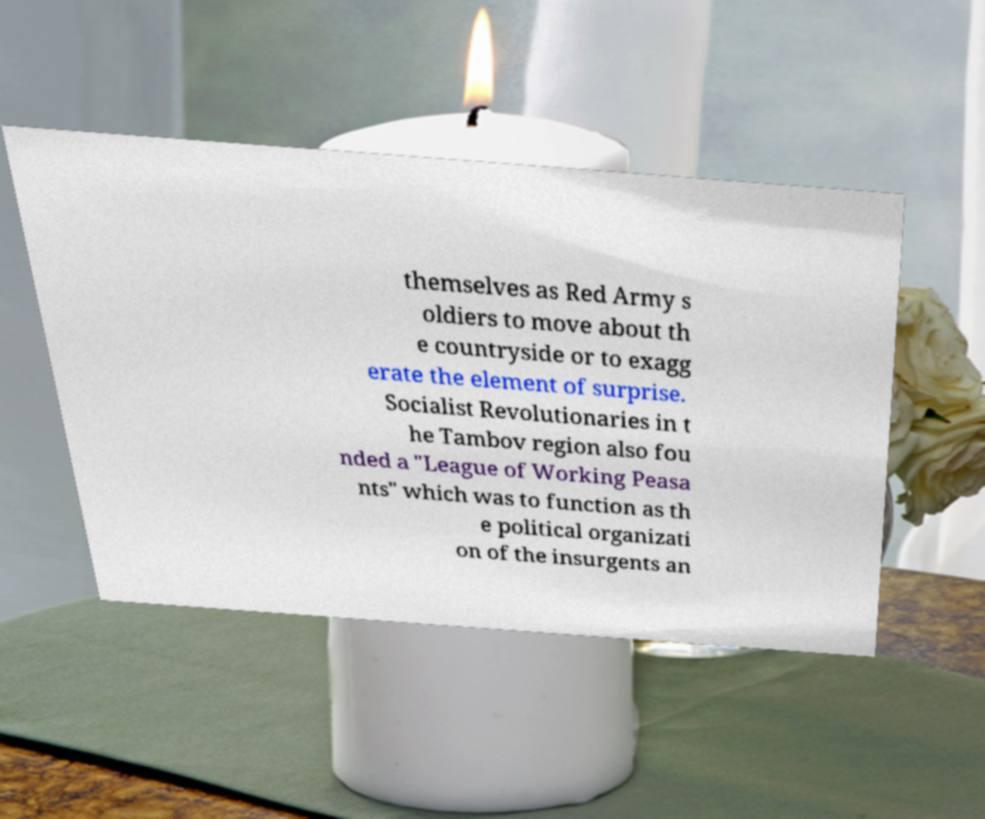Please identify and transcribe the text found in this image. themselves as Red Army s oldiers to move about th e countryside or to exagg erate the element of surprise. Socialist Revolutionaries in t he Tambov region also fou nded a "League of Working Peasa nts" which was to function as th e political organizati on of the insurgents an 